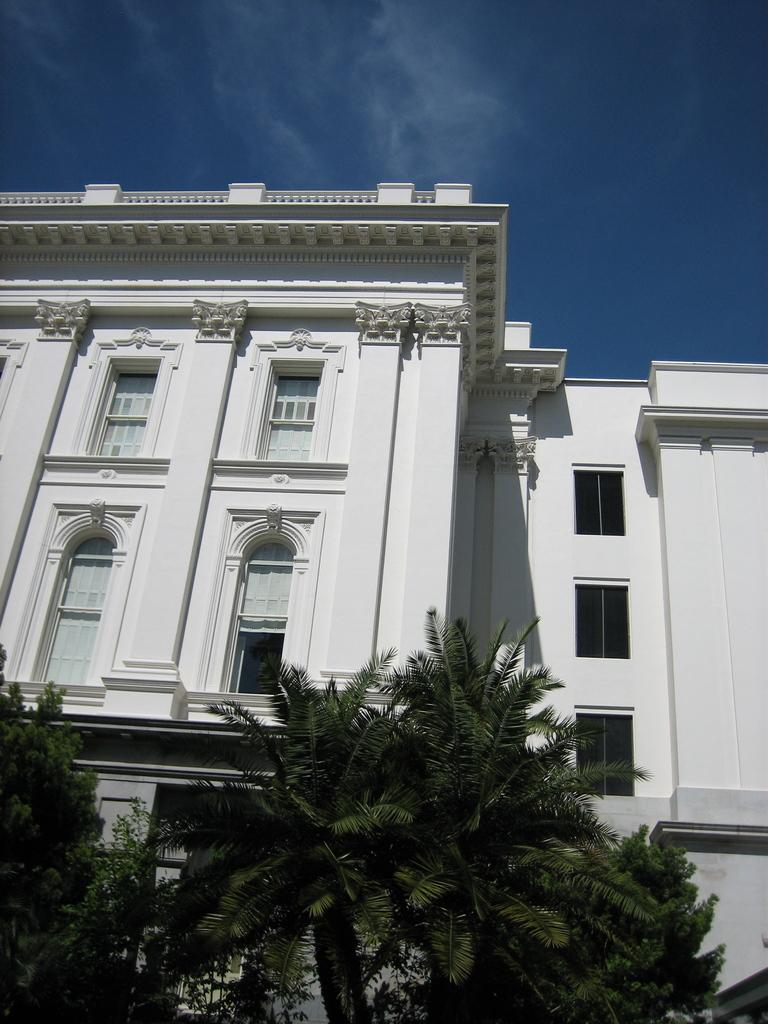What type of vegetation is present at the bottom of the image? There are trees in the bottom of the image. What type of structure can be seen in the background of the image? There is a building in the background of the image. What is visible at the top of the image? The sky is visible at the top of the image. Is there a hose being used to water the trees in the image? There is no hose present in the image. What is the temper of the building in the background? The provided facts do not give any information about the temperature or condition of the building, so we cannot answer this question. 